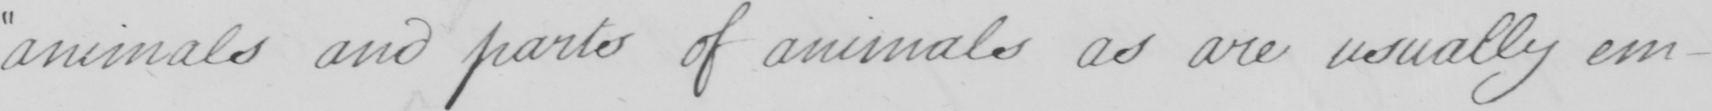What is written in this line of handwriting? animals and parts of animals as are usually em- 